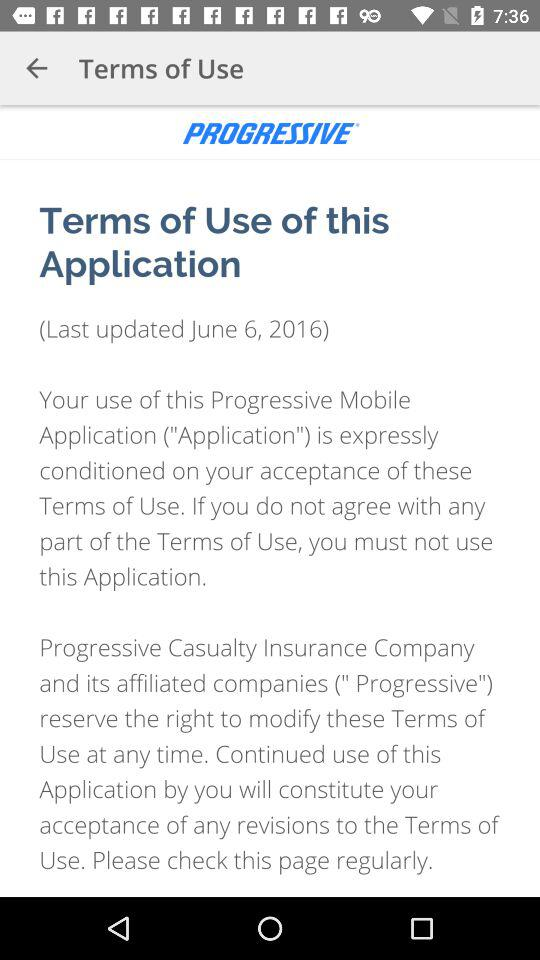What is the name of the application? The name of the application is "PROGRESSIVE". 